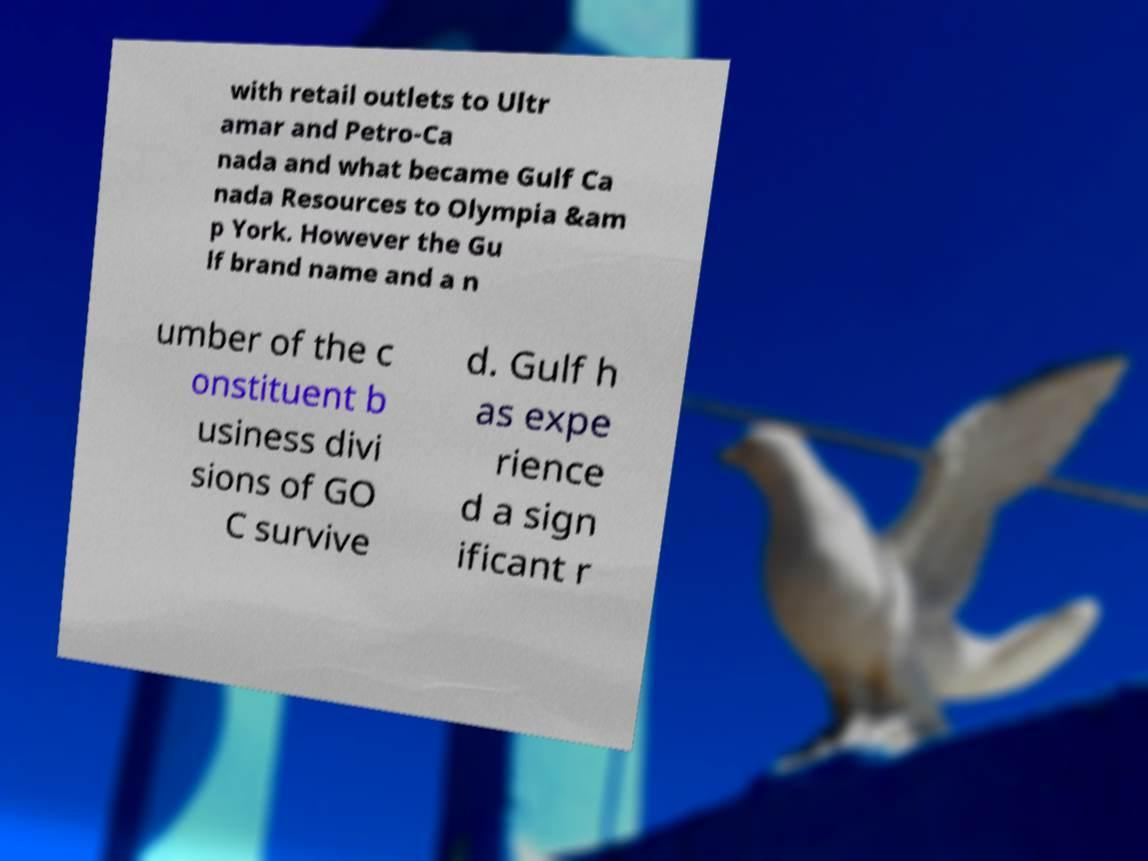What messages or text are displayed in this image? I need them in a readable, typed format. with retail outlets to Ultr amar and Petro-Ca nada and what became Gulf Ca nada Resources to Olympia &am p York. However the Gu lf brand name and a n umber of the c onstituent b usiness divi sions of GO C survive d. Gulf h as expe rience d a sign ificant r 